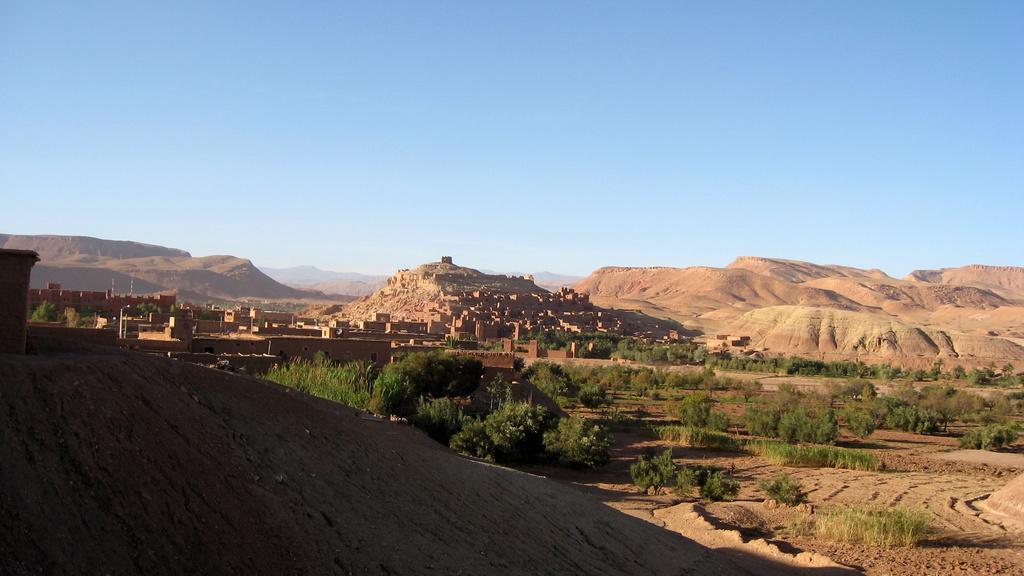Describe this image in one or two sentences. In this picture there are houses and greenery in the center of the image and there is muddy texture in the image. 